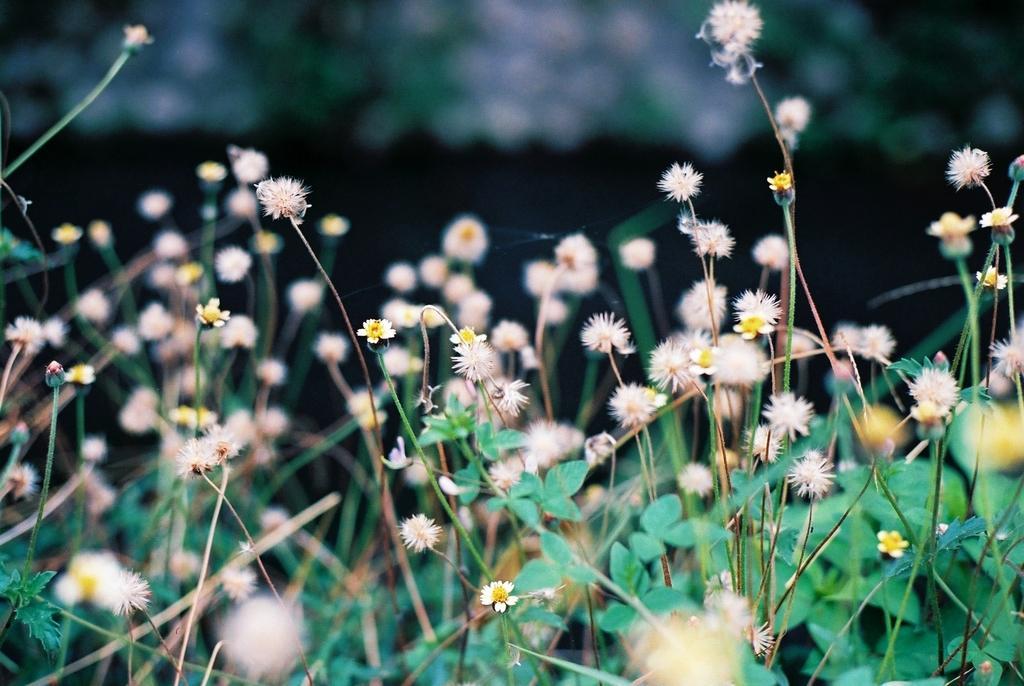Can you describe this image briefly? In this image I can see there are flower plants. 